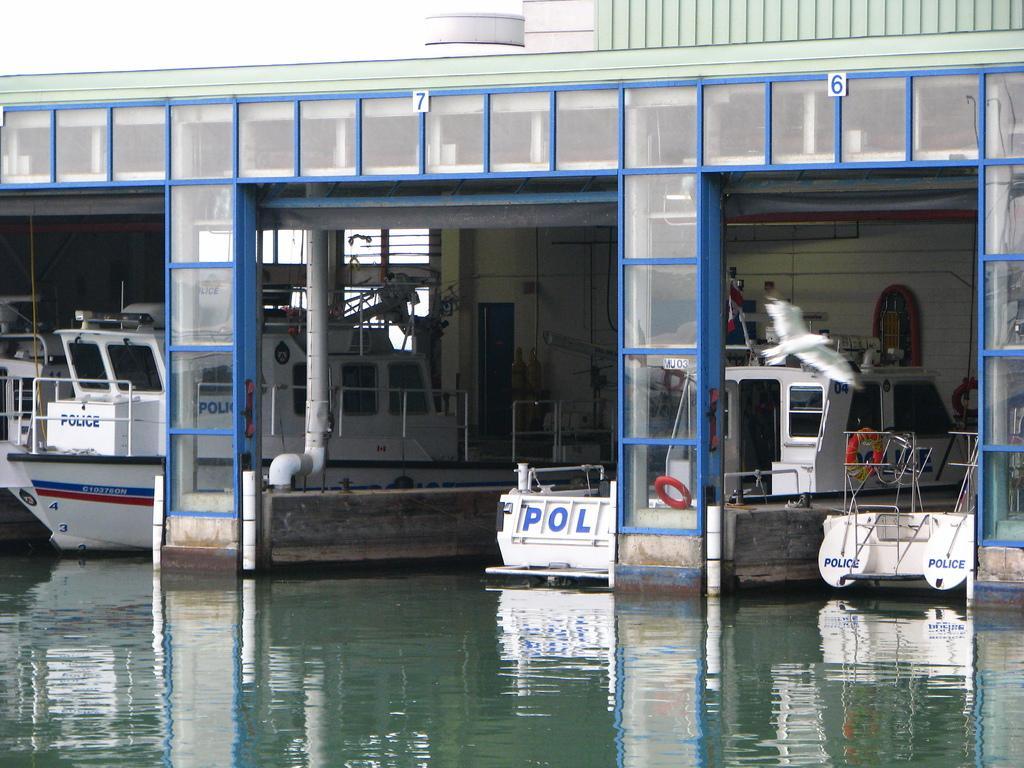Could you give a brief overview of what you see in this image? This image consists of boats. There is a bird on the right side. It is in white color. There is water at the bottom. 